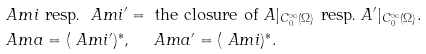Convert formula to latex. <formula><loc_0><loc_0><loc_500><loc_500>& \ A m i \text { resp.\ } \ A m i ^ { \prime } = \text { the closure of } A | _ { C _ { 0 } ^ { \infty } ( \Omega ) } \text { resp.\ } A ^ { \prime } | _ { C _ { 0 } ^ { \infty } ( \Omega ) } . \\ & \ A m a = ( \ A m i ^ { \prime } ) ^ { * } , \quad \ A m a ^ { \prime } = ( \ A m i ) ^ { * } .</formula> 